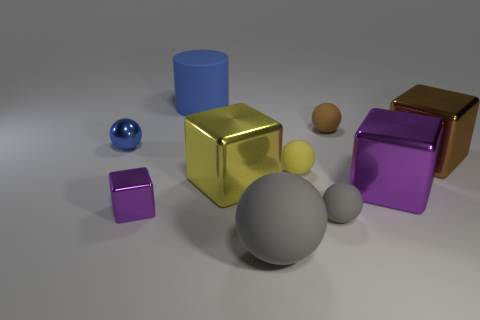Subtract all yellow rubber balls. How many balls are left? 4 Subtract 3 balls. How many balls are left? 2 Subtract all yellow spheres. How many spheres are left? 4 Subtract all cylinders. How many objects are left? 9 Subtract all green cylinders. How many red spheres are left? 0 Subtract all large yellow shiny blocks. Subtract all small shiny objects. How many objects are left? 7 Add 6 small brown spheres. How many small brown spheres are left? 7 Add 1 large brown objects. How many large brown objects exist? 2 Subtract 1 blue balls. How many objects are left? 9 Subtract all blue balls. Subtract all yellow cylinders. How many balls are left? 4 